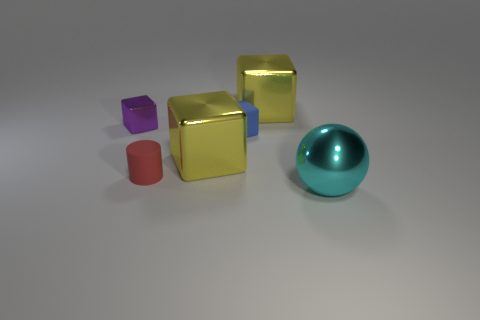Is the color of the cube on the right side of the small blue rubber block the same as the big block that is in front of the small purple shiny cube?
Offer a terse response. Yes. What number of other objects are the same size as the matte cylinder?
Your answer should be very brief. 2. Does the big yellow shiny object that is to the right of the blue rubber block have the same shape as the yellow metallic object that is in front of the small rubber block?
Provide a succinct answer. Yes. There is a tiny metallic cube; what number of big yellow shiny objects are left of it?
Ensure brevity in your answer.  0. What color is the shiny cube in front of the purple cube?
Offer a terse response. Yellow. There is another tiny object that is the same shape as the small shiny thing; what is its color?
Offer a very short reply. Blue. Are there any other things that are the same color as the cylinder?
Your answer should be very brief. No. Are there more small red cylinders than small brown metal cylinders?
Keep it short and to the point. Yes. Are the red object and the cyan ball made of the same material?
Give a very brief answer. No. How many cyan spheres have the same material as the cyan object?
Provide a short and direct response. 0. 